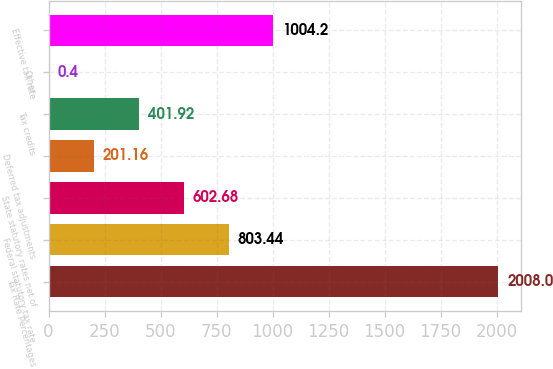Convert chart. <chart><loc_0><loc_0><loc_500><loc_500><bar_chart><fcel>Tax Rate Percentages<fcel>Federal statutory tax rate<fcel>State statutory rates net of<fcel>Deferred tax adjustments<fcel>Tax credits<fcel>Other<fcel>Effective tax rate<nl><fcel>2008<fcel>803.44<fcel>602.68<fcel>201.16<fcel>401.92<fcel>0.4<fcel>1004.2<nl></chart> 